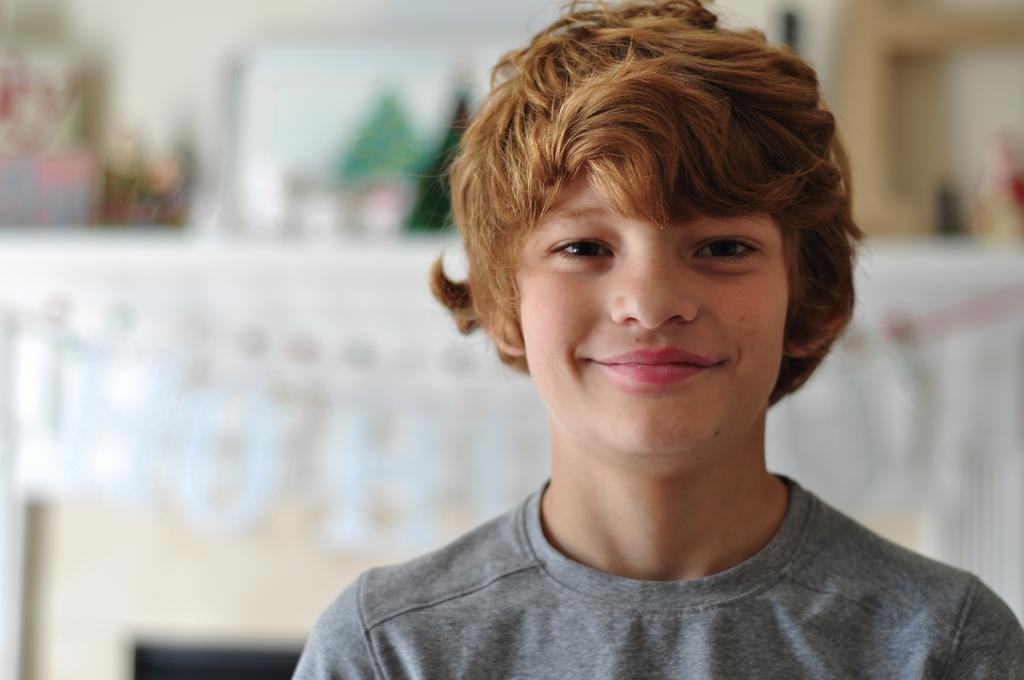Who is the main subject in the image? There is a boy in the image. What is the boy wearing? The boy is wearing a t-shirt. What is the boy's facial expression in the image? The boy is smiling. Can you describe the background of the image? There are blurred objects in the background of the image. What type of milk is the goose drinking in the image? There is no goose or milk present in the image. Does the existence of the boy in the image prove the existence of extraterrestrial life? The presence of the boy in the image does not prove the existence of extraterrestrial life, as the image only shows a boy and does not contain any information about extraterrestrial life. 